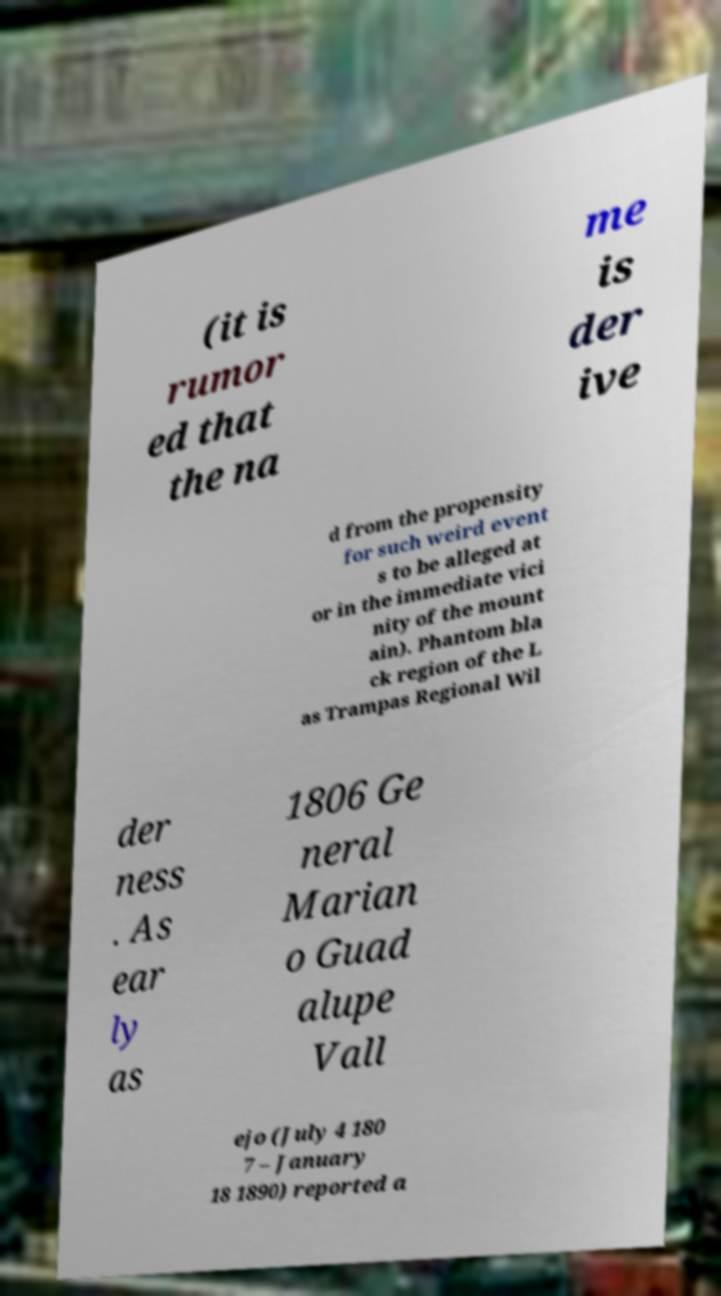Please identify and transcribe the text found in this image. (it is rumor ed that the na me is der ive d from the propensity for such weird event s to be alleged at or in the immediate vici nity of the mount ain). Phantom bla ck region of the L as Trampas Regional Wil der ness . As ear ly as 1806 Ge neral Marian o Guad alupe Vall ejo (July 4 180 7 – January 18 1890) reported a 